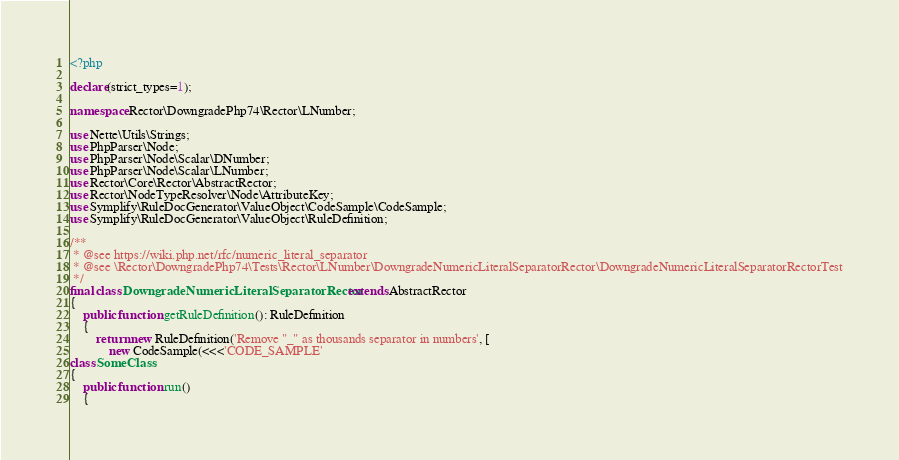Convert code to text. <code><loc_0><loc_0><loc_500><loc_500><_PHP_><?php

declare(strict_types=1);

namespace Rector\DowngradePhp74\Rector\LNumber;

use Nette\Utils\Strings;
use PhpParser\Node;
use PhpParser\Node\Scalar\DNumber;
use PhpParser\Node\Scalar\LNumber;
use Rector\Core\Rector\AbstractRector;
use Rector\NodeTypeResolver\Node\AttributeKey;
use Symplify\RuleDocGenerator\ValueObject\CodeSample\CodeSample;
use Symplify\RuleDocGenerator\ValueObject\RuleDefinition;

/**
 * @see https://wiki.php.net/rfc/numeric_literal_separator
 * @see \Rector\DowngradePhp74\Tests\Rector\LNumber\DowngradeNumericLiteralSeparatorRector\DowngradeNumericLiteralSeparatorRectorTest
 */
final class DowngradeNumericLiteralSeparatorRector extends AbstractRector
{
    public function getRuleDefinition(): RuleDefinition
    {
        return new RuleDefinition('Remove "_" as thousands separator in numbers', [
            new CodeSample(<<<'CODE_SAMPLE'
class SomeClass
{
    public function run()
    {</code> 